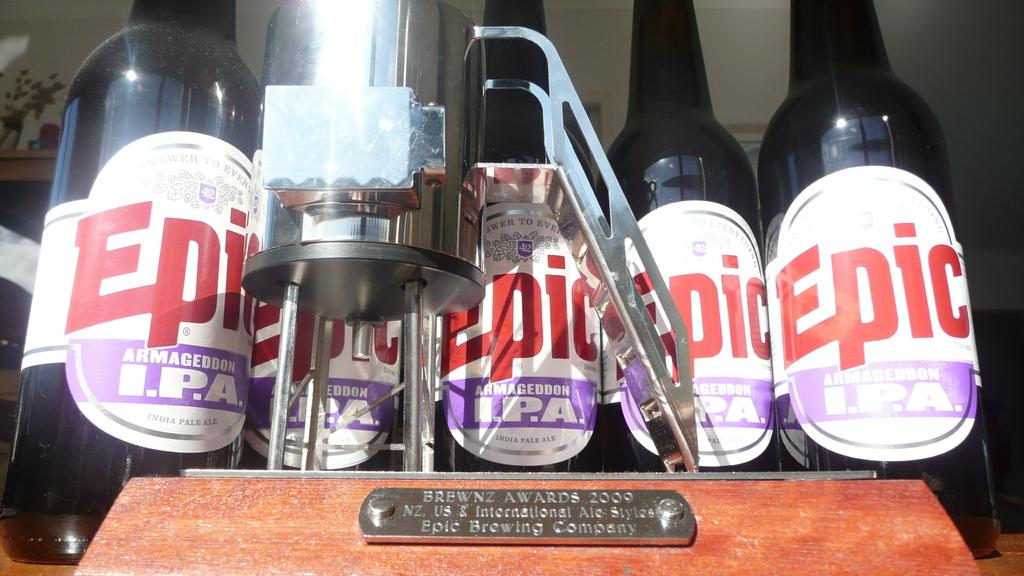<image>
Write a terse but informative summary of the picture. four bottles lined up  across a shelf that the bottle say epic and they are in front of a magnifier glass 